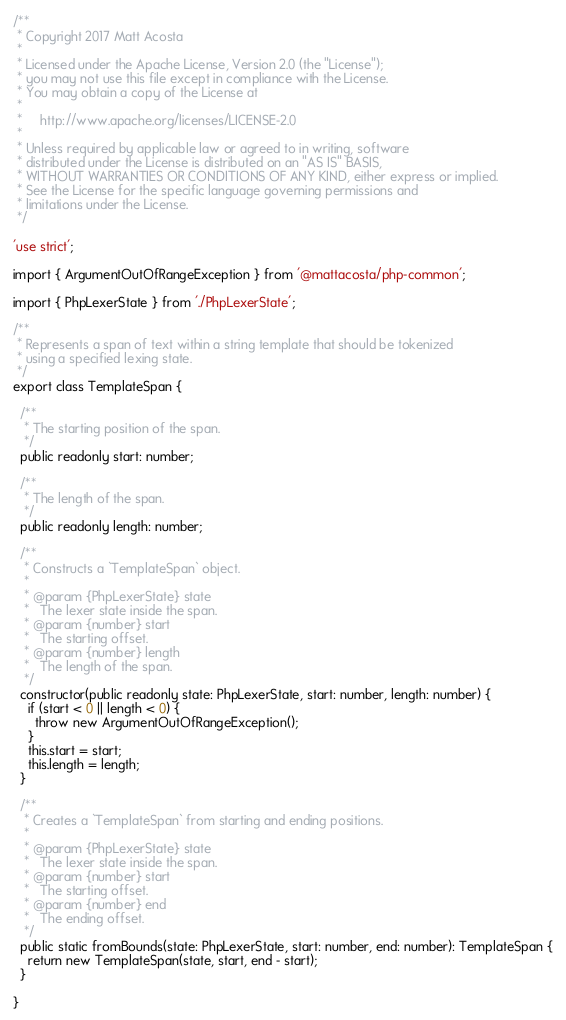<code> <loc_0><loc_0><loc_500><loc_500><_TypeScript_>/**
 * Copyright 2017 Matt Acosta
 *
 * Licensed under the Apache License, Version 2.0 (the "License");
 * you may not use this file except in compliance with the License.
 * You may obtain a copy of the License at
 *
 *     http://www.apache.org/licenses/LICENSE-2.0
 *
 * Unless required by applicable law or agreed to in writing, software
 * distributed under the License is distributed on an "AS IS" BASIS,
 * WITHOUT WARRANTIES OR CONDITIONS OF ANY KIND, either express or implied.
 * See the License for the specific language governing permissions and
 * limitations under the License.
 */

'use strict';

import { ArgumentOutOfRangeException } from '@mattacosta/php-common';

import { PhpLexerState } from './PhpLexerState';

/**
 * Represents a span of text within a string template that should be tokenized
 * using a specified lexing state.
 */
export class TemplateSpan {

  /**
   * The starting position of the span.
   */
  public readonly start: number;

  /**
   * The length of the span.
   */
  public readonly length: number;

  /**
   * Constructs a `TemplateSpan` object.
   *
   * @param {PhpLexerState} state
   *   The lexer state inside the span.
   * @param {number} start
   *   The starting offset.
   * @param {number} length
   *   The length of the span.
   */
  constructor(public readonly state: PhpLexerState, start: number, length: number) {
    if (start < 0 || length < 0) {
      throw new ArgumentOutOfRangeException();
    }
    this.start = start;
    this.length = length;
  }

  /**
   * Creates a `TemplateSpan` from starting and ending positions.
   *
   * @param {PhpLexerState} state
   *   The lexer state inside the span.
   * @param {number} start
   *   The starting offset.
   * @param {number} end
   *   The ending offset.
   */
  public static fromBounds(state: PhpLexerState, start: number, end: number): TemplateSpan {
    return new TemplateSpan(state, start, end - start);
  }

}
</code> 